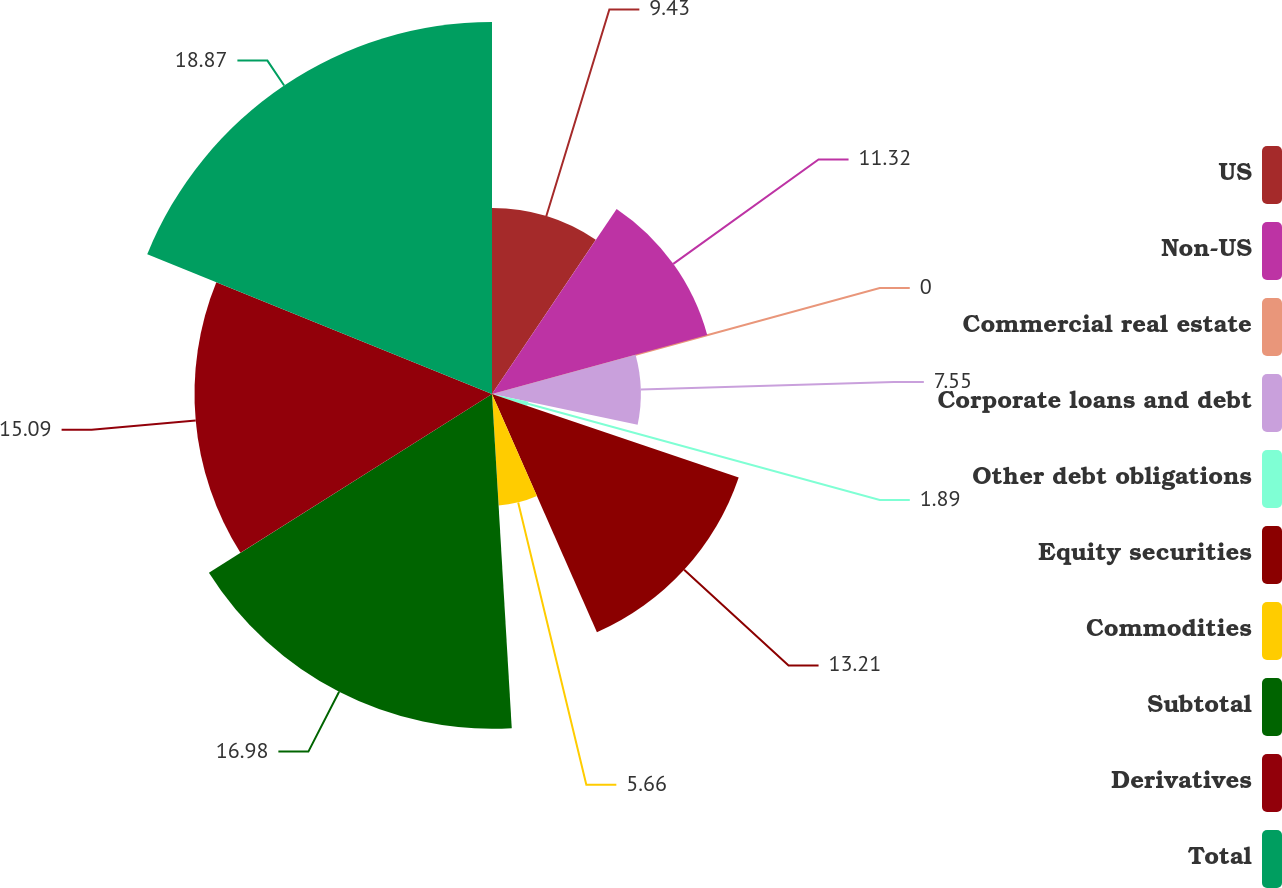Convert chart to OTSL. <chart><loc_0><loc_0><loc_500><loc_500><pie_chart><fcel>US<fcel>Non-US<fcel>Commercial real estate<fcel>Corporate loans and debt<fcel>Other debt obligations<fcel>Equity securities<fcel>Commodities<fcel>Subtotal<fcel>Derivatives<fcel>Total<nl><fcel>9.43%<fcel>11.32%<fcel>0.0%<fcel>7.55%<fcel>1.89%<fcel>13.21%<fcel>5.66%<fcel>16.98%<fcel>15.09%<fcel>18.87%<nl></chart> 